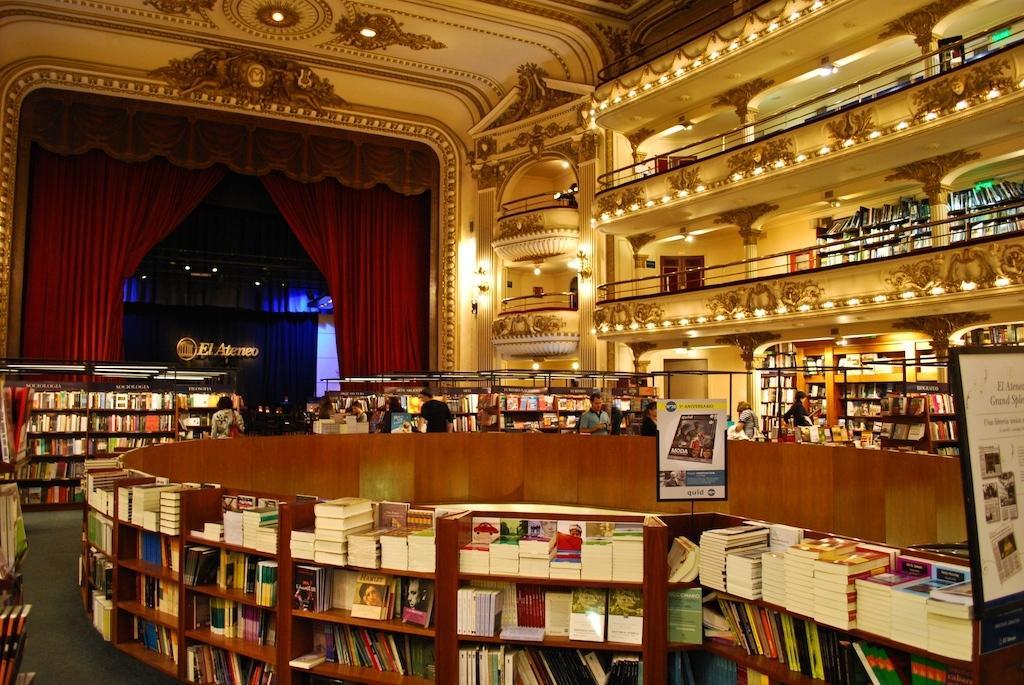Could you give a brief overview of what you see in this image? In this image, we can see so many shelves filled with books. Here we can see a board, poster, railings, walls, lights, curtains. In the middle of the image, we can see a group of people. 